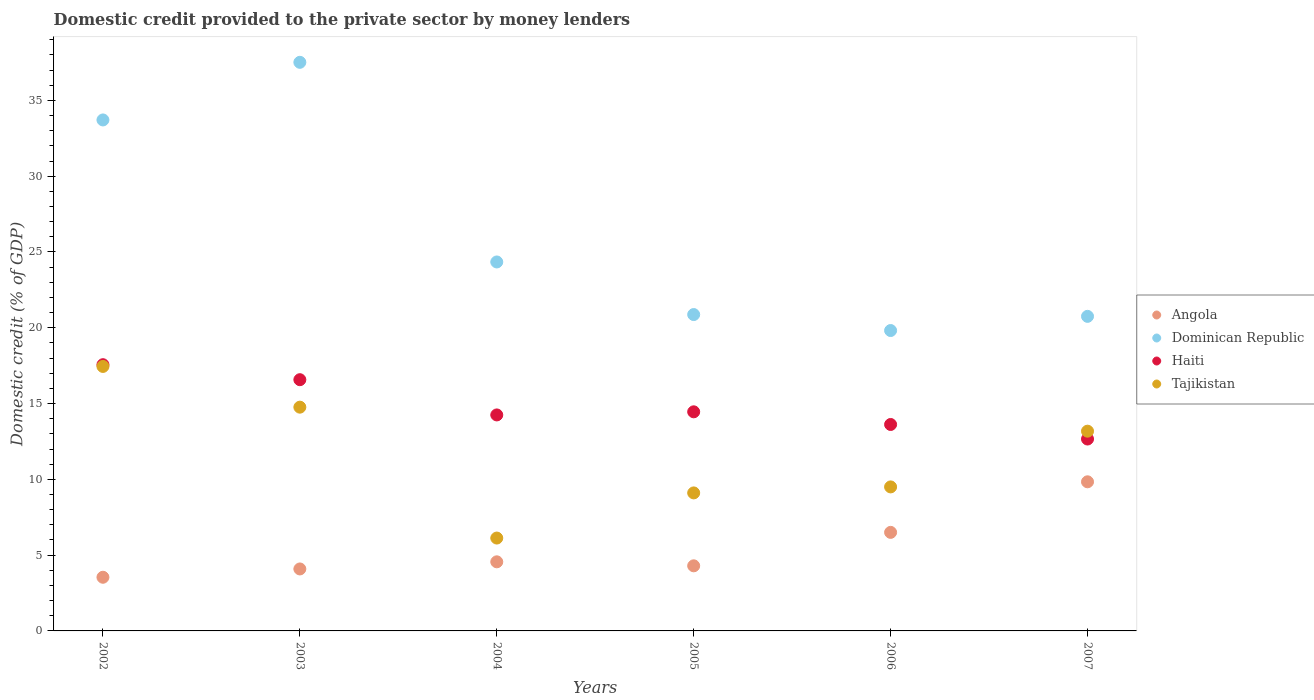What is the domestic credit provided to the private sector by money lenders in Dominican Republic in 2005?
Ensure brevity in your answer.  20.87. Across all years, what is the maximum domestic credit provided to the private sector by money lenders in Dominican Republic?
Offer a very short reply. 37.51. Across all years, what is the minimum domestic credit provided to the private sector by money lenders in Dominican Republic?
Your answer should be very brief. 19.82. In which year was the domestic credit provided to the private sector by money lenders in Tajikistan minimum?
Offer a terse response. 2004. What is the total domestic credit provided to the private sector by money lenders in Haiti in the graph?
Offer a very short reply. 89.12. What is the difference between the domestic credit provided to the private sector by money lenders in Angola in 2004 and that in 2007?
Provide a succinct answer. -5.28. What is the difference between the domestic credit provided to the private sector by money lenders in Angola in 2002 and the domestic credit provided to the private sector by money lenders in Haiti in 2003?
Give a very brief answer. -13.03. What is the average domestic credit provided to the private sector by money lenders in Tajikistan per year?
Provide a succinct answer. 11.69. In the year 2007, what is the difference between the domestic credit provided to the private sector by money lenders in Tajikistan and domestic credit provided to the private sector by money lenders in Angola?
Offer a terse response. 3.34. In how many years, is the domestic credit provided to the private sector by money lenders in Haiti greater than 27 %?
Provide a succinct answer. 0. What is the ratio of the domestic credit provided to the private sector by money lenders in Tajikistan in 2005 to that in 2007?
Your answer should be very brief. 0.69. Is the domestic credit provided to the private sector by money lenders in Haiti in 2006 less than that in 2007?
Provide a short and direct response. No. Is the difference between the domestic credit provided to the private sector by money lenders in Tajikistan in 2003 and 2006 greater than the difference between the domestic credit provided to the private sector by money lenders in Angola in 2003 and 2006?
Your response must be concise. Yes. What is the difference between the highest and the second highest domestic credit provided to the private sector by money lenders in Haiti?
Provide a short and direct response. 0.99. What is the difference between the highest and the lowest domestic credit provided to the private sector by money lenders in Dominican Republic?
Provide a short and direct response. 17.7. In how many years, is the domestic credit provided to the private sector by money lenders in Dominican Republic greater than the average domestic credit provided to the private sector by money lenders in Dominican Republic taken over all years?
Make the answer very short. 2. Is the sum of the domestic credit provided to the private sector by money lenders in Tajikistan in 2002 and 2005 greater than the maximum domestic credit provided to the private sector by money lenders in Angola across all years?
Your answer should be compact. Yes. Does the domestic credit provided to the private sector by money lenders in Tajikistan monotonically increase over the years?
Keep it short and to the point. No. Is the domestic credit provided to the private sector by money lenders in Haiti strictly greater than the domestic credit provided to the private sector by money lenders in Dominican Republic over the years?
Give a very brief answer. No. Is the domestic credit provided to the private sector by money lenders in Angola strictly less than the domestic credit provided to the private sector by money lenders in Haiti over the years?
Your answer should be very brief. Yes. What is the difference between two consecutive major ticks on the Y-axis?
Provide a short and direct response. 5. Does the graph contain grids?
Provide a succinct answer. No. Where does the legend appear in the graph?
Your answer should be very brief. Center right. How are the legend labels stacked?
Offer a terse response. Vertical. What is the title of the graph?
Your answer should be very brief. Domestic credit provided to the private sector by money lenders. What is the label or title of the Y-axis?
Your answer should be very brief. Domestic credit (% of GDP). What is the Domestic credit (% of GDP) in Angola in 2002?
Provide a short and direct response. 3.54. What is the Domestic credit (% of GDP) of Dominican Republic in 2002?
Your response must be concise. 33.71. What is the Domestic credit (% of GDP) of Haiti in 2002?
Make the answer very short. 17.56. What is the Domestic credit (% of GDP) of Tajikistan in 2002?
Make the answer very short. 17.45. What is the Domestic credit (% of GDP) of Angola in 2003?
Provide a short and direct response. 4.09. What is the Domestic credit (% of GDP) in Dominican Republic in 2003?
Provide a short and direct response. 37.51. What is the Domestic credit (% of GDP) in Haiti in 2003?
Your answer should be compact. 16.57. What is the Domestic credit (% of GDP) in Tajikistan in 2003?
Your answer should be compact. 14.76. What is the Domestic credit (% of GDP) of Angola in 2004?
Make the answer very short. 4.56. What is the Domestic credit (% of GDP) in Dominican Republic in 2004?
Provide a succinct answer. 24.34. What is the Domestic credit (% of GDP) in Haiti in 2004?
Offer a terse response. 14.25. What is the Domestic credit (% of GDP) of Tajikistan in 2004?
Your response must be concise. 6.13. What is the Domestic credit (% of GDP) of Angola in 2005?
Your answer should be very brief. 4.29. What is the Domestic credit (% of GDP) of Dominican Republic in 2005?
Give a very brief answer. 20.87. What is the Domestic credit (% of GDP) of Haiti in 2005?
Offer a very short reply. 14.45. What is the Domestic credit (% of GDP) of Tajikistan in 2005?
Give a very brief answer. 9.11. What is the Domestic credit (% of GDP) of Angola in 2006?
Provide a succinct answer. 6.5. What is the Domestic credit (% of GDP) of Dominican Republic in 2006?
Your answer should be compact. 19.82. What is the Domestic credit (% of GDP) in Haiti in 2006?
Offer a terse response. 13.62. What is the Domestic credit (% of GDP) in Tajikistan in 2006?
Keep it short and to the point. 9.5. What is the Domestic credit (% of GDP) of Angola in 2007?
Your answer should be very brief. 9.84. What is the Domestic credit (% of GDP) in Dominican Republic in 2007?
Your answer should be very brief. 20.75. What is the Domestic credit (% of GDP) of Haiti in 2007?
Your response must be concise. 12.66. What is the Domestic credit (% of GDP) of Tajikistan in 2007?
Keep it short and to the point. 13.18. Across all years, what is the maximum Domestic credit (% of GDP) of Angola?
Your answer should be compact. 9.84. Across all years, what is the maximum Domestic credit (% of GDP) in Dominican Republic?
Your response must be concise. 37.51. Across all years, what is the maximum Domestic credit (% of GDP) of Haiti?
Offer a terse response. 17.56. Across all years, what is the maximum Domestic credit (% of GDP) of Tajikistan?
Offer a very short reply. 17.45. Across all years, what is the minimum Domestic credit (% of GDP) in Angola?
Provide a short and direct response. 3.54. Across all years, what is the minimum Domestic credit (% of GDP) of Dominican Republic?
Give a very brief answer. 19.82. Across all years, what is the minimum Domestic credit (% of GDP) of Haiti?
Provide a succinct answer. 12.66. Across all years, what is the minimum Domestic credit (% of GDP) in Tajikistan?
Ensure brevity in your answer.  6.13. What is the total Domestic credit (% of GDP) in Angola in the graph?
Offer a very short reply. 32.82. What is the total Domestic credit (% of GDP) of Dominican Republic in the graph?
Your response must be concise. 157.01. What is the total Domestic credit (% of GDP) of Haiti in the graph?
Your answer should be compact. 89.12. What is the total Domestic credit (% of GDP) in Tajikistan in the graph?
Provide a short and direct response. 70.12. What is the difference between the Domestic credit (% of GDP) of Angola in 2002 and that in 2003?
Provide a succinct answer. -0.55. What is the difference between the Domestic credit (% of GDP) in Dominican Republic in 2002 and that in 2003?
Offer a terse response. -3.8. What is the difference between the Domestic credit (% of GDP) in Haiti in 2002 and that in 2003?
Offer a terse response. 0.99. What is the difference between the Domestic credit (% of GDP) of Tajikistan in 2002 and that in 2003?
Your response must be concise. 2.69. What is the difference between the Domestic credit (% of GDP) of Angola in 2002 and that in 2004?
Keep it short and to the point. -1.02. What is the difference between the Domestic credit (% of GDP) in Dominican Republic in 2002 and that in 2004?
Provide a short and direct response. 9.37. What is the difference between the Domestic credit (% of GDP) in Haiti in 2002 and that in 2004?
Offer a terse response. 3.31. What is the difference between the Domestic credit (% of GDP) of Tajikistan in 2002 and that in 2004?
Your answer should be compact. 11.32. What is the difference between the Domestic credit (% of GDP) of Angola in 2002 and that in 2005?
Provide a succinct answer. -0.75. What is the difference between the Domestic credit (% of GDP) of Dominican Republic in 2002 and that in 2005?
Your answer should be compact. 12.84. What is the difference between the Domestic credit (% of GDP) in Haiti in 2002 and that in 2005?
Your answer should be compact. 3.11. What is the difference between the Domestic credit (% of GDP) in Tajikistan in 2002 and that in 2005?
Ensure brevity in your answer.  8.34. What is the difference between the Domestic credit (% of GDP) in Angola in 2002 and that in 2006?
Keep it short and to the point. -2.96. What is the difference between the Domestic credit (% of GDP) in Dominican Republic in 2002 and that in 2006?
Give a very brief answer. 13.89. What is the difference between the Domestic credit (% of GDP) of Haiti in 2002 and that in 2006?
Your answer should be very brief. 3.94. What is the difference between the Domestic credit (% of GDP) of Tajikistan in 2002 and that in 2006?
Your response must be concise. 7.95. What is the difference between the Domestic credit (% of GDP) of Angola in 2002 and that in 2007?
Make the answer very short. -6.3. What is the difference between the Domestic credit (% of GDP) in Dominican Republic in 2002 and that in 2007?
Offer a terse response. 12.96. What is the difference between the Domestic credit (% of GDP) in Haiti in 2002 and that in 2007?
Ensure brevity in your answer.  4.9. What is the difference between the Domestic credit (% of GDP) in Tajikistan in 2002 and that in 2007?
Your response must be concise. 4.27. What is the difference between the Domestic credit (% of GDP) in Angola in 2003 and that in 2004?
Give a very brief answer. -0.47. What is the difference between the Domestic credit (% of GDP) in Dominican Republic in 2003 and that in 2004?
Keep it short and to the point. 13.17. What is the difference between the Domestic credit (% of GDP) of Haiti in 2003 and that in 2004?
Provide a succinct answer. 2.32. What is the difference between the Domestic credit (% of GDP) in Tajikistan in 2003 and that in 2004?
Offer a terse response. 8.64. What is the difference between the Domestic credit (% of GDP) of Angola in 2003 and that in 2005?
Ensure brevity in your answer.  -0.21. What is the difference between the Domestic credit (% of GDP) of Dominican Republic in 2003 and that in 2005?
Offer a terse response. 16.64. What is the difference between the Domestic credit (% of GDP) of Haiti in 2003 and that in 2005?
Give a very brief answer. 2.12. What is the difference between the Domestic credit (% of GDP) in Tajikistan in 2003 and that in 2005?
Ensure brevity in your answer.  5.66. What is the difference between the Domestic credit (% of GDP) of Angola in 2003 and that in 2006?
Make the answer very short. -2.41. What is the difference between the Domestic credit (% of GDP) of Dominican Republic in 2003 and that in 2006?
Your response must be concise. 17.7. What is the difference between the Domestic credit (% of GDP) in Haiti in 2003 and that in 2006?
Your answer should be very brief. 2.96. What is the difference between the Domestic credit (% of GDP) of Tajikistan in 2003 and that in 2006?
Give a very brief answer. 5.26. What is the difference between the Domestic credit (% of GDP) of Angola in 2003 and that in 2007?
Provide a short and direct response. -5.75. What is the difference between the Domestic credit (% of GDP) of Dominican Republic in 2003 and that in 2007?
Offer a terse response. 16.76. What is the difference between the Domestic credit (% of GDP) of Haiti in 2003 and that in 2007?
Your answer should be very brief. 3.91. What is the difference between the Domestic credit (% of GDP) of Tajikistan in 2003 and that in 2007?
Your answer should be very brief. 1.58. What is the difference between the Domestic credit (% of GDP) in Angola in 2004 and that in 2005?
Offer a terse response. 0.26. What is the difference between the Domestic credit (% of GDP) in Dominican Republic in 2004 and that in 2005?
Offer a terse response. 3.47. What is the difference between the Domestic credit (% of GDP) of Haiti in 2004 and that in 2005?
Your answer should be very brief. -0.21. What is the difference between the Domestic credit (% of GDP) in Tajikistan in 2004 and that in 2005?
Provide a succinct answer. -2.98. What is the difference between the Domestic credit (% of GDP) in Angola in 2004 and that in 2006?
Your response must be concise. -1.94. What is the difference between the Domestic credit (% of GDP) in Dominican Republic in 2004 and that in 2006?
Your answer should be compact. 4.52. What is the difference between the Domestic credit (% of GDP) of Haiti in 2004 and that in 2006?
Keep it short and to the point. 0.63. What is the difference between the Domestic credit (% of GDP) of Tajikistan in 2004 and that in 2006?
Provide a succinct answer. -3.37. What is the difference between the Domestic credit (% of GDP) of Angola in 2004 and that in 2007?
Provide a succinct answer. -5.28. What is the difference between the Domestic credit (% of GDP) of Dominican Republic in 2004 and that in 2007?
Provide a succinct answer. 3.59. What is the difference between the Domestic credit (% of GDP) of Haiti in 2004 and that in 2007?
Provide a short and direct response. 1.59. What is the difference between the Domestic credit (% of GDP) of Tajikistan in 2004 and that in 2007?
Give a very brief answer. -7.05. What is the difference between the Domestic credit (% of GDP) of Angola in 2005 and that in 2006?
Make the answer very short. -2.21. What is the difference between the Domestic credit (% of GDP) in Dominican Republic in 2005 and that in 2006?
Keep it short and to the point. 1.05. What is the difference between the Domestic credit (% of GDP) in Haiti in 2005 and that in 2006?
Your response must be concise. 0.84. What is the difference between the Domestic credit (% of GDP) in Tajikistan in 2005 and that in 2006?
Offer a terse response. -0.4. What is the difference between the Domestic credit (% of GDP) in Angola in 2005 and that in 2007?
Provide a succinct answer. -5.54. What is the difference between the Domestic credit (% of GDP) in Dominican Republic in 2005 and that in 2007?
Keep it short and to the point. 0.12. What is the difference between the Domestic credit (% of GDP) in Haiti in 2005 and that in 2007?
Your response must be concise. 1.8. What is the difference between the Domestic credit (% of GDP) in Tajikistan in 2005 and that in 2007?
Provide a short and direct response. -4.07. What is the difference between the Domestic credit (% of GDP) in Angola in 2006 and that in 2007?
Keep it short and to the point. -3.34. What is the difference between the Domestic credit (% of GDP) in Dominican Republic in 2006 and that in 2007?
Offer a very short reply. -0.94. What is the difference between the Domestic credit (% of GDP) of Haiti in 2006 and that in 2007?
Offer a terse response. 0.96. What is the difference between the Domestic credit (% of GDP) in Tajikistan in 2006 and that in 2007?
Offer a terse response. -3.68. What is the difference between the Domestic credit (% of GDP) of Angola in 2002 and the Domestic credit (% of GDP) of Dominican Republic in 2003?
Your response must be concise. -33.97. What is the difference between the Domestic credit (% of GDP) in Angola in 2002 and the Domestic credit (% of GDP) in Haiti in 2003?
Make the answer very short. -13.03. What is the difference between the Domestic credit (% of GDP) of Angola in 2002 and the Domestic credit (% of GDP) of Tajikistan in 2003?
Keep it short and to the point. -11.22. What is the difference between the Domestic credit (% of GDP) of Dominican Republic in 2002 and the Domestic credit (% of GDP) of Haiti in 2003?
Your response must be concise. 17.14. What is the difference between the Domestic credit (% of GDP) of Dominican Republic in 2002 and the Domestic credit (% of GDP) of Tajikistan in 2003?
Your answer should be compact. 18.95. What is the difference between the Domestic credit (% of GDP) in Haiti in 2002 and the Domestic credit (% of GDP) in Tajikistan in 2003?
Keep it short and to the point. 2.8. What is the difference between the Domestic credit (% of GDP) of Angola in 2002 and the Domestic credit (% of GDP) of Dominican Republic in 2004?
Give a very brief answer. -20.8. What is the difference between the Domestic credit (% of GDP) of Angola in 2002 and the Domestic credit (% of GDP) of Haiti in 2004?
Provide a short and direct response. -10.71. What is the difference between the Domestic credit (% of GDP) of Angola in 2002 and the Domestic credit (% of GDP) of Tajikistan in 2004?
Your response must be concise. -2.59. What is the difference between the Domestic credit (% of GDP) of Dominican Republic in 2002 and the Domestic credit (% of GDP) of Haiti in 2004?
Ensure brevity in your answer.  19.46. What is the difference between the Domestic credit (% of GDP) in Dominican Republic in 2002 and the Domestic credit (% of GDP) in Tajikistan in 2004?
Your answer should be compact. 27.58. What is the difference between the Domestic credit (% of GDP) of Haiti in 2002 and the Domestic credit (% of GDP) of Tajikistan in 2004?
Offer a very short reply. 11.44. What is the difference between the Domestic credit (% of GDP) in Angola in 2002 and the Domestic credit (% of GDP) in Dominican Republic in 2005?
Offer a terse response. -17.33. What is the difference between the Domestic credit (% of GDP) of Angola in 2002 and the Domestic credit (% of GDP) of Haiti in 2005?
Your answer should be very brief. -10.91. What is the difference between the Domestic credit (% of GDP) in Angola in 2002 and the Domestic credit (% of GDP) in Tajikistan in 2005?
Your answer should be compact. -5.57. What is the difference between the Domestic credit (% of GDP) in Dominican Republic in 2002 and the Domestic credit (% of GDP) in Haiti in 2005?
Your answer should be compact. 19.26. What is the difference between the Domestic credit (% of GDP) of Dominican Republic in 2002 and the Domestic credit (% of GDP) of Tajikistan in 2005?
Offer a terse response. 24.61. What is the difference between the Domestic credit (% of GDP) in Haiti in 2002 and the Domestic credit (% of GDP) in Tajikistan in 2005?
Ensure brevity in your answer.  8.46. What is the difference between the Domestic credit (% of GDP) in Angola in 2002 and the Domestic credit (% of GDP) in Dominican Republic in 2006?
Give a very brief answer. -16.28. What is the difference between the Domestic credit (% of GDP) in Angola in 2002 and the Domestic credit (% of GDP) in Haiti in 2006?
Your response must be concise. -10.08. What is the difference between the Domestic credit (% of GDP) of Angola in 2002 and the Domestic credit (% of GDP) of Tajikistan in 2006?
Your answer should be very brief. -5.96. What is the difference between the Domestic credit (% of GDP) of Dominican Republic in 2002 and the Domestic credit (% of GDP) of Haiti in 2006?
Offer a very short reply. 20.09. What is the difference between the Domestic credit (% of GDP) of Dominican Republic in 2002 and the Domestic credit (% of GDP) of Tajikistan in 2006?
Provide a short and direct response. 24.21. What is the difference between the Domestic credit (% of GDP) in Haiti in 2002 and the Domestic credit (% of GDP) in Tajikistan in 2006?
Offer a terse response. 8.06. What is the difference between the Domestic credit (% of GDP) of Angola in 2002 and the Domestic credit (% of GDP) of Dominican Republic in 2007?
Your answer should be very brief. -17.21. What is the difference between the Domestic credit (% of GDP) of Angola in 2002 and the Domestic credit (% of GDP) of Haiti in 2007?
Your response must be concise. -9.12. What is the difference between the Domestic credit (% of GDP) in Angola in 2002 and the Domestic credit (% of GDP) in Tajikistan in 2007?
Your answer should be very brief. -9.64. What is the difference between the Domestic credit (% of GDP) of Dominican Republic in 2002 and the Domestic credit (% of GDP) of Haiti in 2007?
Make the answer very short. 21.05. What is the difference between the Domestic credit (% of GDP) in Dominican Republic in 2002 and the Domestic credit (% of GDP) in Tajikistan in 2007?
Make the answer very short. 20.53. What is the difference between the Domestic credit (% of GDP) of Haiti in 2002 and the Domestic credit (% of GDP) of Tajikistan in 2007?
Ensure brevity in your answer.  4.39. What is the difference between the Domestic credit (% of GDP) in Angola in 2003 and the Domestic credit (% of GDP) in Dominican Republic in 2004?
Give a very brief answer. -20.25. What is the difference between the Domestic credit (% of GDP) of Angola in 2003 and the Domestic credit (% of GDP) of Haiti in 2004?
Make the answer very short. -10.16. What is the difference between the Domestic credit (% of GDP) of Angola in 2003 and the Domestic credit (% of GDP) of Tajikistan in 2004?
Make the answer very short. -2.04. What is the difference between the Domestic credit (% of GDP) in Dominican Republic in 2003 and the Domestic credit (% of GDP) in Haiti in 2004?
Keep it short and to the point. 23.26. What is the difference between the Domestic credit (% of GDP) of Dominican Republic in 2003 and the Domestic credit (% of GDP) of Tajikistan in 2004?
Provide a succinct answer. 31.39. What is the difference between the Domestic credit (% of GDP) of Haiti in 2003 and the Domestic credit (% of GDP) of Tajikistan in 2004?
Offer a terse response. 10.45. What is the difference between the Domestic credit (% of GDP) of Angola in 2003 and the Domestic credit (% of GDP) of Dominican Republic in 2005?
Keep it short and to the point. -16.78. What is the difference between the Domestic credit (% of GDP) in Angola in 2003 and the Domestic credit (% of GDP) in Haiti in 2005?
Your answer should be very brief. -10.37. What is the difference between the Domestic credit (% of GDP) in Angola in 2003 and the Domestic credit (% of GDP) in Tajikistan in 2005?
Your response must be concise. -5.02. What is the difference between the Domestic credit (% of GDP) of Dominican Republic in 2003 and the Domestic credit (% of GDP) of Haiti in 2005?
Give a very brief answer. 23.06. What is the difference between the Domestic credit (% of GDP) of Dominican Republic in 2003 and the Domestic credit (% of GDP) of Tajikistan in 2005?
Your answer should be compact. 28.41. What is the difference between the Domestic credit (% of GDP) in Haiti in 2003 and the Domestic credit (% of GDP) in Tajikistan in 2005?
Keep it short and to the point. 7.47. What is the difference between the Domestic credit (% of GDP) of Angola in 2003 and the Domestic credit (% of GDP) of Dominican Republic in 2006?
Your answer should be compact. -15.73. What is the difference between the Domestic credit (% of GDP) in Angola in 2003 and the Domestic credit (% of GDP) in Haiti in 2006?
Give a very brief answer. -9.53. What is the difference between the Domestic credit (% of GDP) of Angola in 2003 and the Domestic credit (% of GDP) of Tajikistan in 2006?
Your response must be concise. -5.41. What is the difference between the Domestic credit (% of GDP) in Dominican Republic in 2003 and the Domestic credit (% of GDP) in Haiti in 2006?
Your answer should be compact. 23.89. What is the difference between the Domestic credit (% of GDP) of Dominican Republic in 2003 and the Domestic credit (% of GDP) of Tajikistan in 2006?
Offer a terse response. 28.01. What is the difference between the Domestic credit (% of GDP) in Haiti in 2003 and the Domestic credit (% of GDP) in Tajikistan in 2006?
Keep it short and to the point. 7.07. What is the difference between the Domestic credit (% of GDP) of Angola in 2003 and the Domestic credit (% of GDP) of Dominican Republic in 2007?
Give a very brief answer. -16.66. What is the difference between the Domestic credit (% of GDP) in Angola in 2003 and the Domestic credit (% of GDP) in Haiti in 2007?
Your answer should be very brief. -8.57. What is the difference between the Domestic credit (% of GDP) of Angola in 2003 and the Domestic credit (% of GDP) of Tajikistan in 2007?
Your response must be concise. -9.09. What is the difference between the Domestic credit (% of GDP) of Dominican Republic in 2003 and the Domestic credit (% of GDP) of Haiti in 2007?
Keep it short and to the point. 24.85. What is the difference between the Domestic credit (% of GDP) of Dominican Republic in 2003 and the Domestic credit (% of GDP) of Tajikistan in 2007?
Give a very brief answer. 24.33. What is the difference between the Domestic credit (% of GDP) in Haiti in 2003 and the Domestic credit (% of GDP) in Tajikistan in 2007?
Provide a succinct answer. 3.4. What is the difference between the Domestic credit (% of GDP) of Angola in 2004 and the Domestic credit (% of GDP) of Dominican Republic in 2005?
Ensure brevity in your answer.  -16.31. What is the difference between the Domestic credit (% of GDP) of Angola in 2004 and the Domestic credit (% of GDP) of Haiti in 2005?
Keep it short and to the point. -9.9. What is the difference between the Domestic credit (% of GDP) in Angola in 2004 and the Domestic credit (% of GDP) in Tajikistan in 2005?
Your response must be concise. -4.55. What is the difference between the Domestic credit (% of GDP) of Dominican Republic in 2004 and the Domestic credit (% of GDP) of Haiti in 2005?
Offer a very short reply. 9.89. What is the difference between the Domestic credit (% of GDP) of Dominican Republic in 2004 and the Domestic credit (% of GDP) of Tajikistan in 2005?
Offer a terse response. 15.24. What is the difference between the Domestic credit (% of GDP) in Haiti in 2004 and the Domestic credit (% of GDP) in Tajikistan in 2005?
Your response must be concise. 5.14. What is the difference between the Domestic credit (% of GDP) in Angola in 2004 and the Domestic credit (% of GDP) in Dominican Republic in 2006?
Ensure brevity in your answer.  -15.26. What is the difference between the Domestic credit (% of GDP) of Angola in 2004 and the Domestic credit (% of GDP) of Haiti in 2006?
Keep it short and to the point. -9.06. What is the difference between the Domestic credit (% of GDP) of Angola in 2004 and the Domestic credit (% of GDP) of Tajikistan in 2006?
Offer a very short reply. -4.94. What is the difference between the Domestic credit (% of GDP) of Dominican Republic in 2004 and the Domestic credit (% of GDP) of Haiti in 2006?
Your response must be concise. 10.72. What is the difference between the Domestic credit (% of GDP) in Dominican Republic in 2004 and the Domestic credit (% of GDP) in Tajikistan in 2006?
Ensure brevity in your answer.  14.84. What is the difference between the Domestic credit (% of GDP) of Haiti in 2004 and the Domestic credit (% of GDP) of Tajikistan in 2006?
Provide a succinct answer. 4.75. What is the difference between the Domestic credit (% of GDP) in Angola in 2004 and the Domestic credit (% of GDP) in Dominican Republic in 2007?
Give a very brief answer. -16.19. What is the difference between the Domestic credit (% of GDP) in Angola in 2004 and the Domestic credit (% of GDP) in Haiti in 2007?
Your answer should be compact. -8.1. What is the difference between the Domestic credit (% of GDP) of Angola in 2004 and the Domestic credit (% of GDP) of Tajikistan in 2007?
Ensure brevity in your answer.  -8.62. What is the difference between the Domestic credit (% of GDP) of Dominican Republic in 2004 and the Domestic credit (% of GDP) of Haiti in 2007?
Keep it short and to the point. 11.68. What is the difference between the Domestic credit (% of GDP) in Dominican Republic in 2004 and the Domestic credit (% of GDP) in Tajikistan in 2007?
Offer a terse response. 11.16. What is the difference between the Domestic credit (% of GDP) of Haiti in 2004 and the Domestic credit (% of GDP) of Tajikistan in 2007?
Offer a terse response. 1.07. What is the difference between the Domestic credit (% of GDP) in Angola in 2005 and the Domestic credit (% of GDP) in Dominican Republic in 2006?
Your response must be concise. -15.52. What is the difference between the Domestic credit (% of GDP) of Angola in 2005 and the Domestic credit (% of GDP) of Haiti in 2006?
Give a very brief answer. -9.32. What is the difference between the Domestic credit (% of GDP) of Angola in 2005 and the Domestic credit (% of GDP) of Tajikistan in 2006?
Your answer should be compact. -5.21. What is the difference between the Domestic credit (% of GDP) of Dominican Republic in 2005 and the Domestic credit (% of GDP) of Haiti in 2006?
Your answer should be compact. 7.25. What is the difference between the Domestic credit (% of GDP) of Dominican Republic in 2005 and the Domestic credit (% of GDP) of Tajikistan in 2006?
Ensure brevity in your answer.  11.37. What is the difference between the Domestic credit (% of GDP) in Haiti in 2005 and the Domestic credit (% of GDP) in Tajikistan in 2006?
Your answer should be compact. 4.95. What is the difference between the Domestic credit (% of GDP) of Angola in 2005 and the Domestic credit (% of GDP) of Dominican Republic in 2007?
Your answer should be very brief. -16.46. What is the difference between the Domestic credit (% of GDP) of Angola in 2005 and the Domestic credit (% of GDP) of Haiti in 2007?
Keep it short and to the point. -8.36. What is the difference between the Domestic credit (% of GDP) in Angola in 2005 and the Domestic credit (% of GDP) in Tajikistan in 2007?
Provide a short and direct response. -8.88. What is the difference between the Domestic credit (% of GDP) of Dominican Republic in 2005 and the Domestic credit (% of GDP) of Haiti in 2007?
Your response must be concise. 8.21. What is the difference between the Domestic credit (% of GDP) in Dominican Republic in 2005 and the Domestic credit (% of GDP) in Tajikistan in 2007?
Provide a short and direct response. 7.69. What is the difference between the Domestic credit (% of GDP) in Haiti in 2005 and the Domestic credit (% of GDP) in Tajikistan in 2007?
Your response must be concise. 1.28. What is the difference between the Domestic credit (% of GDP) of Angola in 2006 and the Domestic credit (% of GDP) of Dominican Republic in 2007?
Keep it short and to the point. -14.25. What is the difference between the Domestic credit (% of GDP) of Angola in 2006 and the Domestic credit (% of GDP) of Haiti in 2007?
Make the answer very short. -6.16. What is the difference between the Domestic credit (% of GDP) in Angola in 2006 and the Domestic credit (% of GDP) in Tajikistan in 2007?
Provide a succinct answer. -6.68. What is the difference between the Domestic credit (% of GDP) of Dominican Republic in 2006 and the Domestic credit (% of GDP) of Haiti in 2007?
Your answer should be very brief. 7.16. What is the difference between the Domestic credit (% of GDP) in Dominican Republic in 2006 and the Domestic credit (% of GDP) in Tajikistan in 2007?
Your answer should be very brief. 6.64. What is the difference between the Domestic credit (% of GDP) in Haiti in 2006 and the Domestic credit (% of GDP) in Tajikistan in 2007?
Provide a short and direct response. 0.44. What is the average Domestic credit (% of GDP) in Angola per year?
Your response must be concise. 5.47. What is the average Domestic credit (% of GDP) of Dominican Republic per year?
Keep it short and to the point. 26.17. What is the average Domestic credit (% of GDP) of Haiti per year?
Offer a very short reply. 14.85. What is the average Domestic credit (% of GDP) of Tajikistan per year?
Offer a very short reply. 11.69. In the year 2002, what is the difference between the Domestic credit (% of GDP) in Angola and Domestic credit (% of GDP) in Dominican Republic?
Provide a short and direct response. -30.17. In the year 2002, what is the difference between the Domestic credit (% of GDP) in Angola and Domestic credit (% of GDP) in Haiti?
Offer a very short reply. -14.02. In the year 2002, what is the difference between the Domestic credit (% of GDP) of Angola and Domestic credit (% of GDP) of Tajikistan?
Give a very brief answer. -13.91. In the year 2002, what is the difference between the Domestic credit (% of GDP) of Dominican Republic and Domestic credit (% of GDP) of Haiti?
Your answer should be very brief. 16.15. In the year 2002, what is the difference between the Domestic credit (% of GDP) of Dominican Republic and Domestic credit (% of GDP) of Tajikistan?
Provide a short and direct response. 16.26. In the year 2002, what is the difference between the Domestic credit (% of GDP) in Haiti and Domestic credit (% of GDP) in Tajikistan?
Your answer should be compact. 0.11. In the year 2003, what is the difference between the Domestic credit (% of GDP) of Angola and Domestic credit (% of GDP) of Dominican Republic?
Your answer should be very brief. -33.42. In the year 2003, what is the difference between the Domestic credit (% of GDP) in Angola and Domestic credit (% of GDP) in Haiti?
Your answer should be very brief. -12.49. In the year 2003, what is the difference between the Domestic credit (% of GDP) of Angola and Domestic credit (% of GDP) of Tajikistan?
Your answer should be compact. -10.67. In the year 2003, what is the difference between the Domestic credit (% of GDP) of Dominican Republic and Domestic credit (% of GDP) of Haiti?
Keep it short and to the point. 20.94. In the year 2003, what is the difference between the Domestic credit (% of GDP) of Dominican Republic and Domestic credit (% of GDP) of Tajikistan?
Provide a short and direct response. 22.75. In the year 2003, what is the difference between the Domestic credit (% of GDP) of Haiti and Domestic credit (% of GDP) of Tajikistan?
Make the answer very short. 1.81. In the year 2004, what is the difference between the Domestic credit (% of GDP) in Angola and Domestic credit (% of GDP) in Dominican Republic?
Keep it short and to the point. -19.78. In the year 2004, what is the difference between the Domestic credit (% of GDP) in Angola and Domestic credit (% of GDP) in Haiti?
Give a very brief answer. -9.69. In the year 2004, what is the difference between the Domestic credit (% of GDP) of Angola and Domestic credit (% of GDP) of Tajikistan?
Your answer should be compact. -1.57. In the year 2004, what is the difference between the Domestic credit (% of GDP) of Dominican Republic and Domestic credit (% of GDP) of Haiti?
Ensure brevity in your answer.  10.09. In the year 2004, what is the difference between the Domestic credit (% of GDP) of Dominican Republic and Domestic credit (% of GDP) of Tajikistan?
Give a very brief answer. 18.21. In the year 2004, what is the difference between the Domestic credit (% of GDP) of Haiti and Domestic credit (% of GDP) of Tajikistan?
Provide a succinct answer. 8.12. In the year 2005, what is the difference between the Domestic credit (% of GDP) in Angola and Domestic credit (% of GDP) in Dominican Republic?
Provide a short and direct response. -16.58. In the year 2005, what is the difference between the Domestic credit (% of GDP) of Angola and Domestic credit (% of GDP) of Haiti?
Offer a terse response. -10.16. In the year 2005, what is the difference between the Domestic credit (% of GDP) of Angola and Domestic credit (% of GDP) of Tajikistan?
Provide a short and direct response. -4.81. In the year 2005, what is the difference between the Domestic credit (% of GDP) in Dominican Republic and Domestic credit (% of GDP) in Haiti?
Your answer should be compact. 6.42. In the year 2005, what is the difference between the Domestic credit (% of GDP) of Dominican Republic and Domestic credit (% of GDP) of Tajikistan?
Make the answer very short. 11.77. In the year 2005, what is the difference between the Domestic credit (% of GDP) in Haiti and Domestic credit (% of GDP) in Tajikistan?
Keep it short and to the point. 5.35. In the year 2006, what is the difference between the Domestic credit (% of GDP) of Angola and Domestic credit (% of GDP) of Dominican Republic?
Make the answer very short. -13.32. In the year 2006, what is the difference between the Domestic credit (% of GDP) in Angola and Domestic credit (% of GDP) in Haiti?
Your answer should be compact. -7.12. In the year 2006, what is the difference between the Domestic credit (% of GDP) in Angola and Domestic credit (% of GDP) in Tajikistan?
Offer a terse response. -3. In the year 2006, what is the difference between the Domestic credit (% of GDP) in Dominican Republic and Domestic credit (% of GDP) in Haiti?
Your answer should be very brief. 6.2. In the year 2006, what is the difference between the Domestic credit (% of GDP) of Dominican Republic and Domestic credit (% of GDP) of Tajikistan?
Provide a succinct answer. 10.32. In the year 2006, what is the difference between the Domestic credit (% of GDP) of Haiti and Domestic credit (% of GDP) of Tajikistan?
Give a very brief answer. 4.12. In the year 2007, what is the difference between the Domestic credit (% of GDP) of Angola and Domestic credit (% of GDP) of Dominican Republic?
Your answer should be very brief. -10.92. In the year 2007, what is the difference between the Domestic credit (% of GDP) of Angola and Domestic credit (% of GDP) of Haiti?
Offer a terse response. -2.82. In the year 2007, what is the difference between the Domestic credit (% of GDP) of Angola and Domestic credit (% of GDP) of Tajikistan?
Give a very brief answer. -3.34. In the year 2007, what is the difference between the Domestic credit (% of GDP) in Dominican Republic and Domestic credit (% of GDP) in Haiti?
Your response must be concise. 8.09. In the year 2007, what is the difference between the Domestic credit (% of GDP) in Dominican Republic and Domestic credit (% of GDP) in Tajikistan?
Your response must be concise. 7.58. In the year 2007, what is the difference between the Domestic credit (% of GDP) of Haiti and Domestic credit (% of GDP) of Tajikistan?
Your response must be concise. -0.52. What is the ratio of the Domestic credit (% of GDP) in Angola in 2002 to that in 2003?
Offer a very short reply. 0.87. What is the ratio of the Domestic credit (% of GDP) of Dominican Republic in 2002 to that in 2003?
Provide a short and direct response. 0.9. What is the ratio of the Domestic credit (% of GDP) in Haiti in 2002 to that in 2003?
Keep it short and to the point. 1.06. What is the ratio of the Domestic credit (% of GDP) in Tajikistan in 2002 to that in 2003?
Offer a terse response. 1.18. What is the ratio of the Domestic credit (% of GDP) of Angola in 2002 to that in 2004?
Keep it short and to the point. 0.78. What is the ratio of the Domestic credit (% of GDP) in Dominican Republic in 2002 to that in 2004?
Keep it short and to the point. 1.38. What is the ratio of the Domestic credit (% of GDP) of Haiti in 2002 to that in 2004?
Provide a succinct answer. 1.23. What is the ratio of the Domestic credit (% of GDP) of Tajikistan in 2002 to that in 2004?
Give a very brief answer. 2.85. What is the ratio of the Domestic credit (% of GDP) in Angola in 2002 to that in 2005?
Your response must be concise. 0.82. What is the ratio of the Domestic credit (% of GDP) of Dominican Republic in 2002 to that in 2005?
Keep it short and to the point. 1.62. What is the ratio of the Domestic credit (% of GDP) of Haiti in 2002 to that in 2005?
Make the answer very short. 1.22. What is the ratio of the Domestic credit (% of GDP) in Tajikistan in 2002 to that in 2005?
Your response must be concise. 1.92. What is the ratio of the Domestic credit (% of GDP) of Angola in 2002 to that in 2006?
Offer a very short reply. 0.54. What is the ratio of the Domestic credit (% of GDP) in Dominican Republic in 2002 to that in 2006?
Ensure brevity in your answer.  1.7. What is the ratio of the Domestic credit (% of GDP) of Haiti in 2002 to that in 2006?
Provide a succinct answer. 1.29. What is the ratio of the Domestic credit (% of GDP) of Tajikistan in 2002 to that in 2006?
Your response must be concise. 1.84. What is the ratio of the Domestic credit (% of GDP) in Angola in 2002 to that in 2007?
Offer a terse response. 0.36. What is the ratio of the Domestic credit (% of GDP) of Dominican Republic in 2002 to that in 2007?
Make the answer very short. 1.62. What is the ratio of the Domestic credit (% of GDP) of Haiti in 2002 to that in 2007?
Your response must be concise. 1.39. What is the ratio of the Domestic credit (% of GDP) of Tajikistan in 2002 to that in 2007?
Ensure brevity in your answer.  1.32. What is the ratio of the Domestic credit (% of GDP) in Angola in 2003 to that in 2004?
Your response must be concise. 0.9. What is the ratio of the Domestic credit (% of GDP) in Dominican Republic in 2003 to that in 2004?
Your response must be concise. 1.54. What is the ratio of the Domestic credit (% of GDP) of Haiti in 2003 to that in 2004?
Give a very brief answer. 1.16. What is the ratio of the Domestic credit (% of GDP) in Tajikistan in 2003 to that in 2004?
Provide a succinct answer. 2.41. What is the ratio of the Domestic credit (% of GDP) of Angola in 2003 to that in 2005?
Your answer should be compact. 0.95. What is the ratio of the Domestic credit (% of GDP) of Dominican Republic in 2003 to that in 2005?
Make the answer very short. 1.8. What is the ratio of the Domestic credit (% of GDP) in Haiti in 2003 to that in 2005?
Give a very brief answer. 1.15. What is the ratio of the Domestic credit (% of GDP) of Tajikistan in 2003 to that in 2005?
Offer a very short reply. 1.62. What is the ratio of the Domestic credit (% of GDP) of Angola in 2003 to that in 2006?
Provide a short and direct response. 0.63. What is the ratio of the Domestic credit (% of GDP) of Dominican Republic in 2003 to that in 2006?
Give a very brief answer. 1.89. What is the ratio of the Domestic credit (% of GDP) in Haiti in 2003 to that in 2006?
Your answer should be compact. 1.22. What is the ratio of the Domestic credit (% of GDP) in Tajikistan in 2003 to that in 2006?
Offer a terse response. 1.55. What is the ratio of the Domestic credit (% of GDP) in Angola in 2003 to that in 2007?
Your response must be concise. 0.42. What is the ratio of the Domestic credit (% of GDP) in Dominican Republic in 2003 to that in 2007?
Make the answer very short. 1.81. What is the ratio of the Domestic credit (% of GDP) of Haiti in 2003 to that in 2007?
Give a very brief answer. 1.31. What is the ratio of the Domestic credit (% of GDP) of Tajikistan in 2003 to that in 2007?
Your answer should be compact. 1.12. What is the ratio of the Domestic credit (% of GDP) of Angola in 2004 to that in 2005?
Your answer should be very brief. 1.06. What is the ratio of the Domestic credit (% of GDP) of Dominican Republic in 2004 to that in 2005?
Keep it short and to the point. 1.17. What is the ratio of the Domestic credit (% of GDP) in Haiti in 2004 to that in 2005?
Offer a very short reply. 0.99. What is the ratio of the Domestic credit (% of GDP) of Tajikistan in 2004 to that in 2005?
Provide a succinct answer. 0.67. What is the ratio of the Domestic credit (% of GDP) of Angola in 2004 to that in 2006?
Keep it short and to the point. 0.7. What is the ratio of the Domestic credit (% of GDP) in Dominican Republic in 2004 to that in 2006?
Provide a short and direct response. 1.23. What is the ratio of the Domestic credit (% of GDP) of Haiti in 2004 to that in 2006?
Your answer should be compact. 1.05. What is the ratio of the Domestic credit (% of GDP) of Tajikistan in 2004 to that in 2006?
Your answer should be compact. 0.64. What is the ratio of the Domestic credit (% of GDP) in Angola in 2004 to that in 2007?
Offer a terse response. 0.46. What is the ratio of the Domestic credit (% of GDP) of Dominican Republic in 2004 to that in 2007?
Your answer should be very brief. 1.17. What is the ratio of the Domestic credit (% of GDP) in Haiti in 2004 to that in 2007?
Make the answer very short. 1.13. What is the ratio of the Domestic credit (% of GDP) in Tajikistan in 2004 to that in 2007?
Keep it short and to the point. 0.46. What is the ratio of the Domestic credit (% of GDP) in Angola in 2005 to that in 2006?
Your answer should be compact. 0.66. What is the ratio of the Domestic credit (% of GDP) of Dominican Republic in 2005 to that in 2006?
Give a very brief answer. 1.05. What is the ratio of the Domestic credit (% of GDP) of Haiti in 2005 to that in 2006?
Your response must be concise. 1.06. What is the ratio of the Domestic credit (% of GDP) in Tajikistan in 2005 to that in 2006?
Provide a short and direct response. 0.96. What is the ratio of the Domestic credit (% of GDP) in Angola in 2005 to that in 2007?
Offer a terse response. 0.44. What is the ratio of the Domestic credit (% of GDP) in Dominican Republic in 2005 to that in 2007?
Ensure brevity in your answer.  1.01. What is the ratio of the Domestic credit (% of GDP) of Haiti in 2005 to that in 2007?
Provide a short and direct response. 1.14. What is the ratio of the Domestic credit (% of GDP) in Tajikistan in 2005 to that in 2007?
Make the answer very short. 0.69. What is the ratio of the Domestic credit (% of GDP) of Angola in 2006 to that in 2007?
Give a very brief answer. 0.66. What is the ratio of the Domestic credit (% of GDP) of Dominican Republic in 2006 to that in 2007?
Provide a short and direct response. 0.95. What is the ratio of the Domestic credit (% of GDP) in Haiti in 2006 to that in 2007?
Ensure brevity in your answer.  1.08. What is the ratio of the Domestic credit (% of GDP) of Tajikistan in 2006 to that in 2007?
Provide a succinct answer. 0.72. What is the difference between the highest and the second highest Domestic credit (% of GDP) in Angola?
Give a very brief answer. 3.34. What is the difference between the highest and the second highest Domestic credit (% of GDP) of Dominican Republic?
Make the answer very short. 3.8. What is the difference between the highest and the second highest Domestic credit (% of GDP) of Haiti?
Provide a short and direct response. 0.99. What is the difference between the highest and the second highest Domestic credit (% of GDP) of Tajikistan?
Offer a terse response. 2.69. What is the difference between the highest and the lowest Domestic credit (% of GDP) of Angola?
Your response must be concise. 6.3. What is the difference between the highest and the lowest Domestic credit (% of GDP) of Dominican Republic?
Make the answer very short. 17.7. What is the difference between the highest and the lowest Domestic credit (% of GDP) of Haiti?
Ensure brevity in your answer.  4.9. What is the difference between the highest and the lowest Domestic credit (% of GDP) of Tajikistan?
Keep it short and to the point. 11.32. 